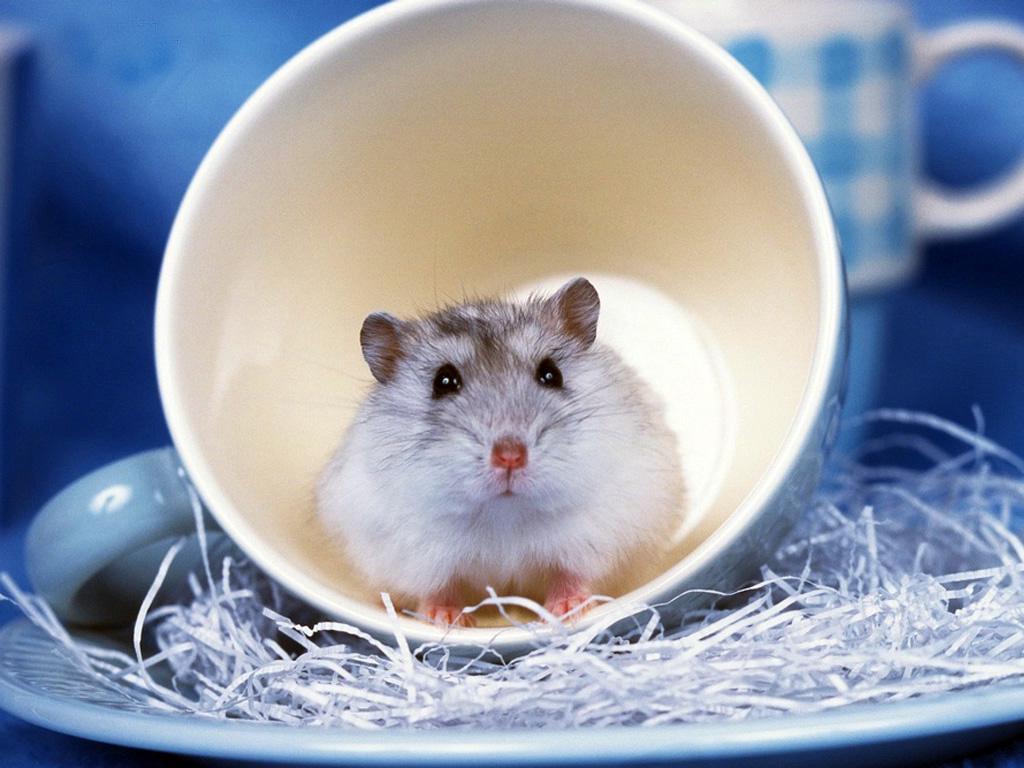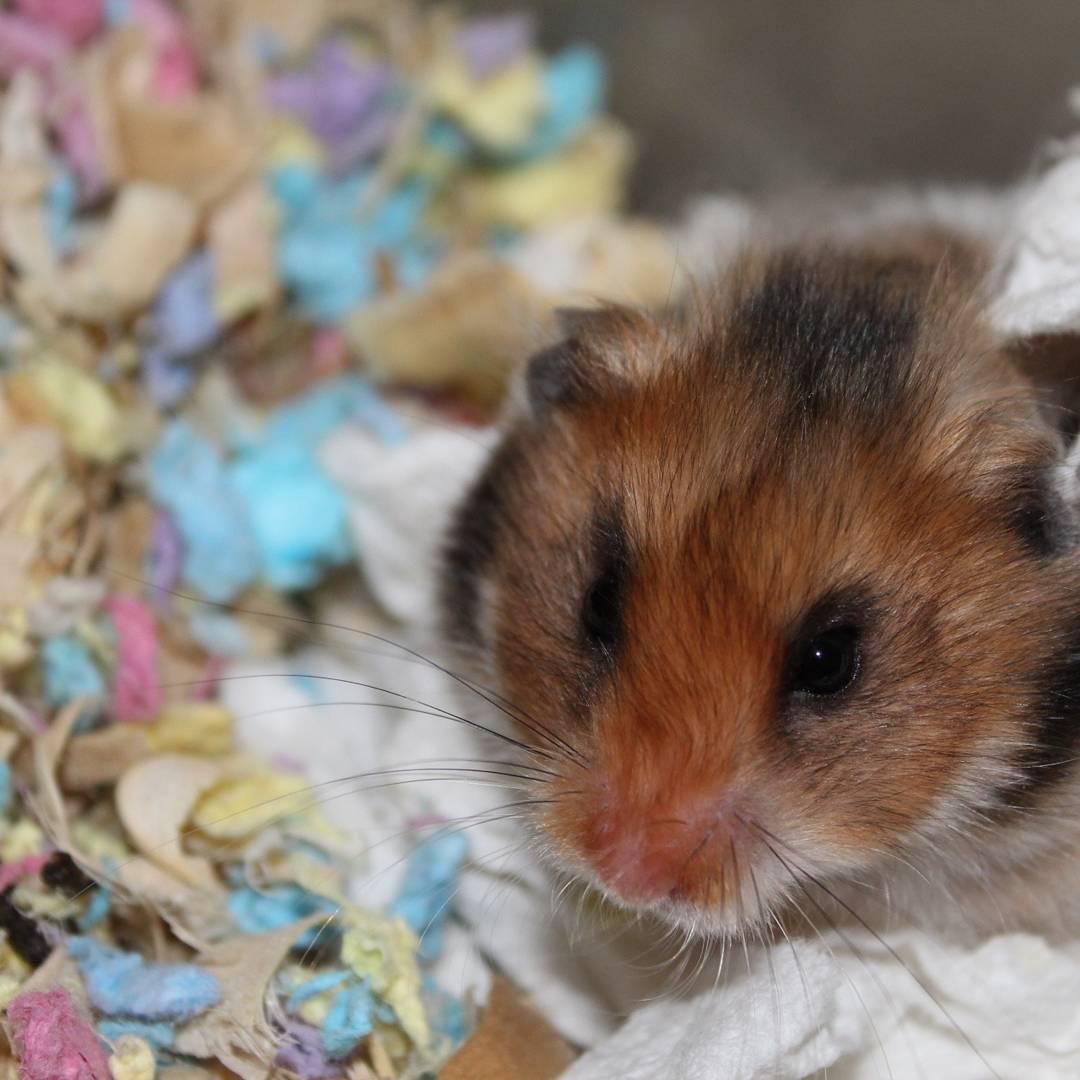The first image is the image on the left, the second image is the image on the right. Examine the images to the left and right. Is the description "Each image shows one hamster with food in front of it, and the right image features a hamster with a peach-colored face clutching a piece of food to its face." accurate? Answer yes or no. No. The first image is the image on the left, the second image is the image on the right. Considering the images on both sides, is "Two hamsters are eating." valid? Answer yes or no. No. 